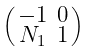Convert formula to latex. <formula><loc_0><loc_0><loc_500><loc_500>\begin{psmallmatrix} - 1 & 0 \\ N _ { 1 } & 1 \end{psmallmatrix}</formula> 